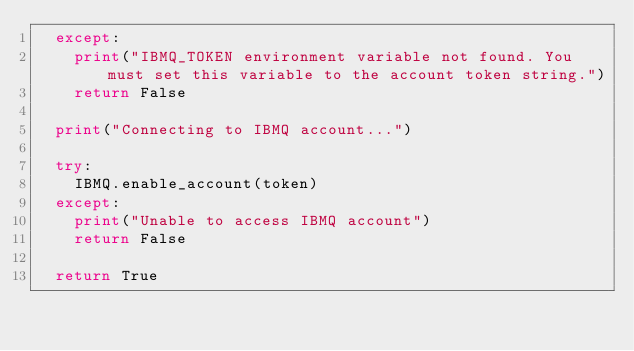Convert code to text. <code><loc_0><loc_0><loc_500><loc_500><_Python_>  except:
    print("IBMQ_TOKEN environment variable not found. You must set this variable to the account token string.")
    return False

  print("Connecting to IBMQ account...")

  try:
    IBMQ.enable_account(token)
  except:
    print("Unable to access IBMQ account")
    return False

  return True
</code> 